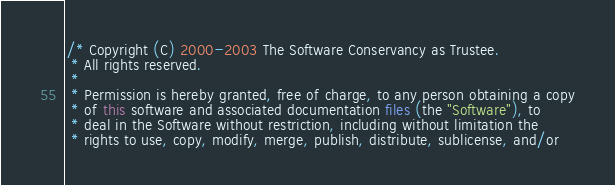Convert code to text. <code><loc_0><loc_0><loc_500><loc_500><_Java_>/* Copyright (C) 2000-2003 The Software Conservancy as Trustee.
 * All rights reserved.
 *
 * Permission is hereby granted, free of charge, to any person obtaining a copy
 * of this software and associated documentation files (the "Software"), to
 * deal in the Software without restriction, including without limitation the
 * rights to use, copy, modify, merge, publish, distribute, sublicense, and/or</code> 